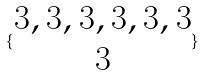<formula> <loc_0><loc_0><loc_500><loc_500>\{ \begin{matrix} 3 , 3 , 3 , 3 , 3 , 3 \\ 3 \end{matrix} \}</formula> 